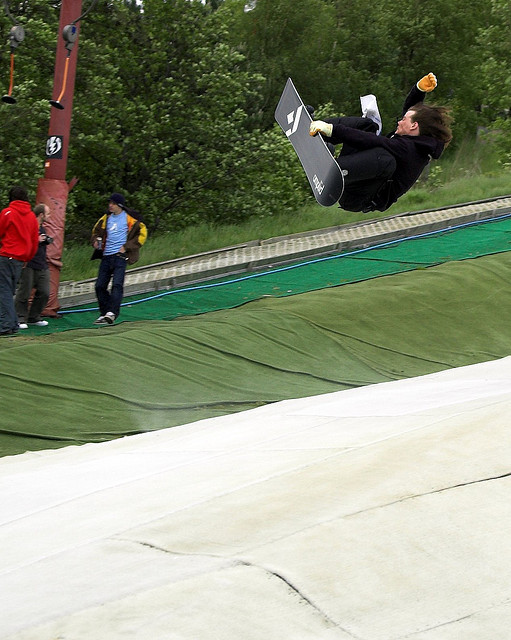Please transcribe the text information in this image. Y 